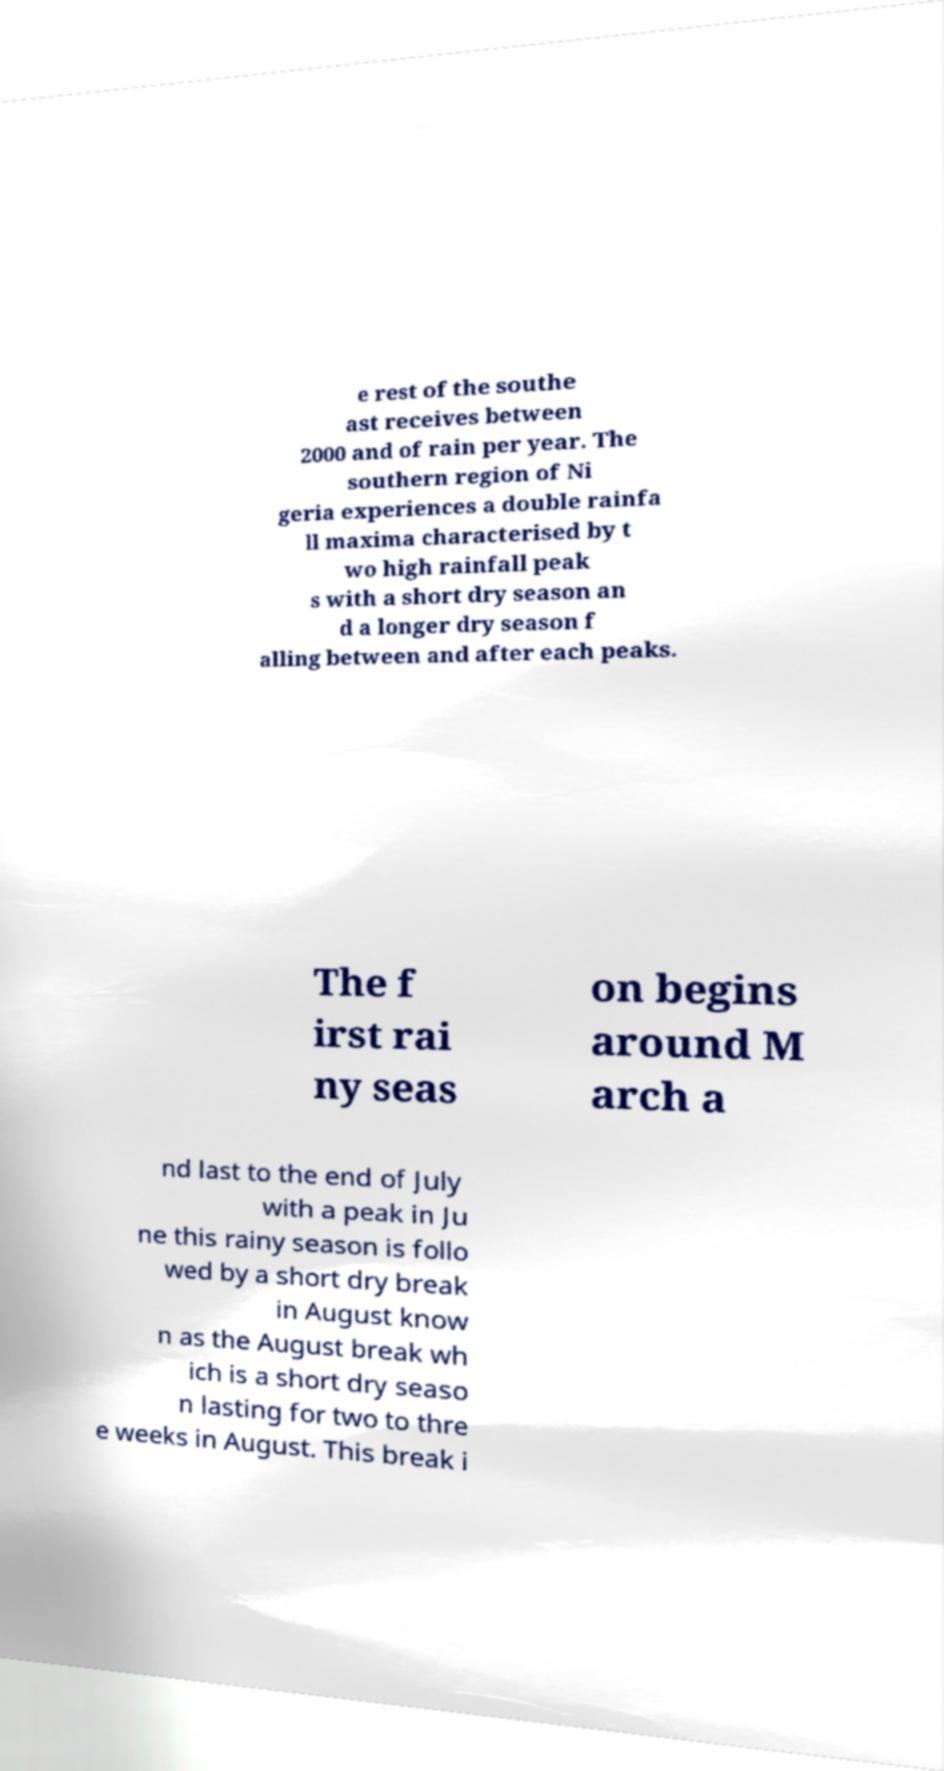Please identify and transcribe the text found in this image. e rest of the southe ast receives between 2000 and of rain per year. The southern region of Ni geria experiences a double rainfa ll maxima characterised by t wo high rainfall peak s with a short dry season an d a longer dry season f alling between and after each peaks. The f irst rai ny seas on begins around M arch a nd last to the end of July with a peak in Ju ne this rainy season is follo wed by a short dry break in August know n as the August break wh ich is a short dry seaso n lasting for two to thre e weeks in August. This break i 